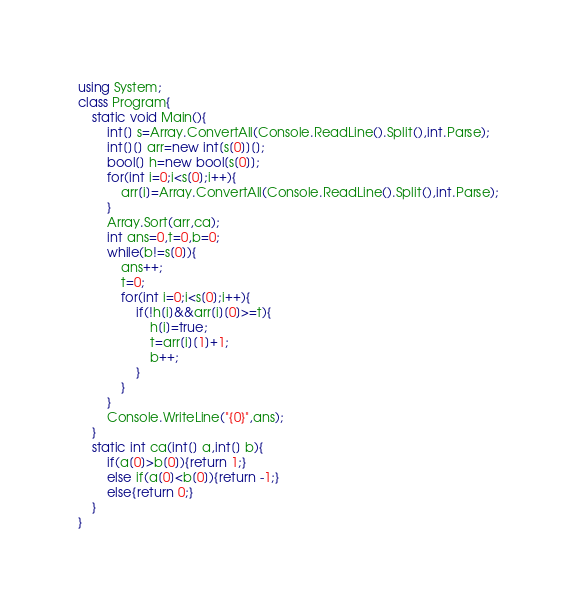<code> <loc_0><loc_0><loc_500><loc_500><_C#_>using System;
class Program{
	static void Main(){
		int[] s=Array.ConvertAll(Console.ReadLine().Split(),int.Parse);
		int[][] arr=new int[s[0]][];
		bool[] h=new bool[s[0]];
		for(int i=0;i<s[0];i++){
			arr[i]=Array.ConvertAll(Console.ReadLine().Split(),int.Parse);
		}
		Array.Sort(arr,ca);
		int ans=0,t=0,b=0;
		while(b!=s[0]){
			ans++;
			t=0;
			for(int i=0;i<s[0];i++){
				if(!h[i]&&arr[i][0]>=t){
					h[i]=true;
					t=arr[i][1]+1;
					b++;
				}
			}
		}
		Console.WriteLine("{0}",ans);
	}
	static int ca(int[] a,int[] b){
		if(a[0]>b[0]){return 1;}
		else if(a[0]<b[0]){return -1;}
		else{return 0;}
	}
}</code> 